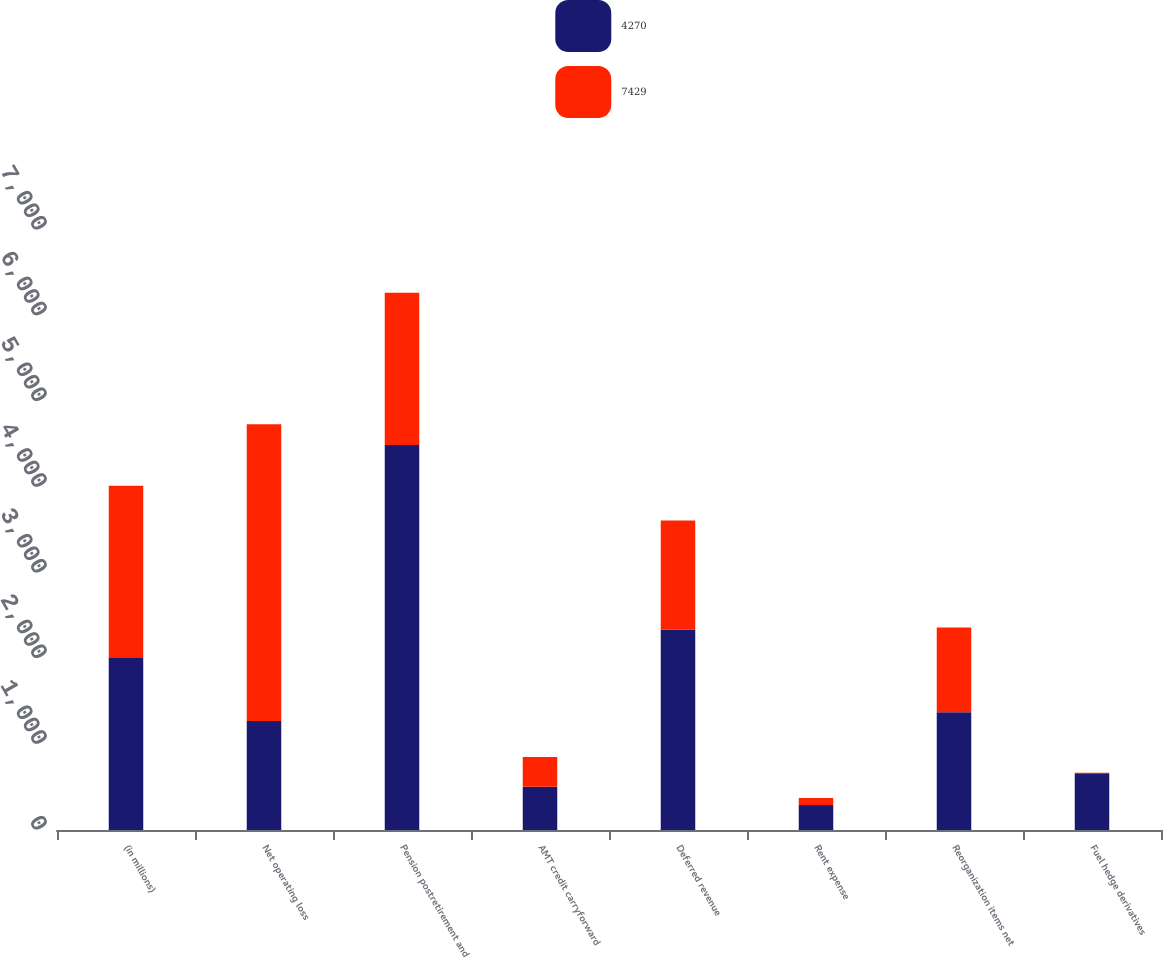Convert chart. <chart><loc_0><loc_0><loc_500><loc_500><stacked_bar_chart><ecel><fcel>(in millions)<fcel>Net operating loss<fcel>Pension postretirement and<fcel>AMT credit carryforward<fcel>Deferred revenue<fcel>Rent expense<fcel>Reorganization items net<fcel>Fuel hedge derivatives<nl><fcel>4270<fcel>2008<fcel>1273<fcel>4491<fcel>505<fcel>2339<fcel>291<fcel>1375<fcel>663<nl><fcel>7429<fcel>2007<fcel>3461<fcel>1778<fcel>346<fcel>1273<fcel>81<fcel>988<fcel>4<nl></chart> 